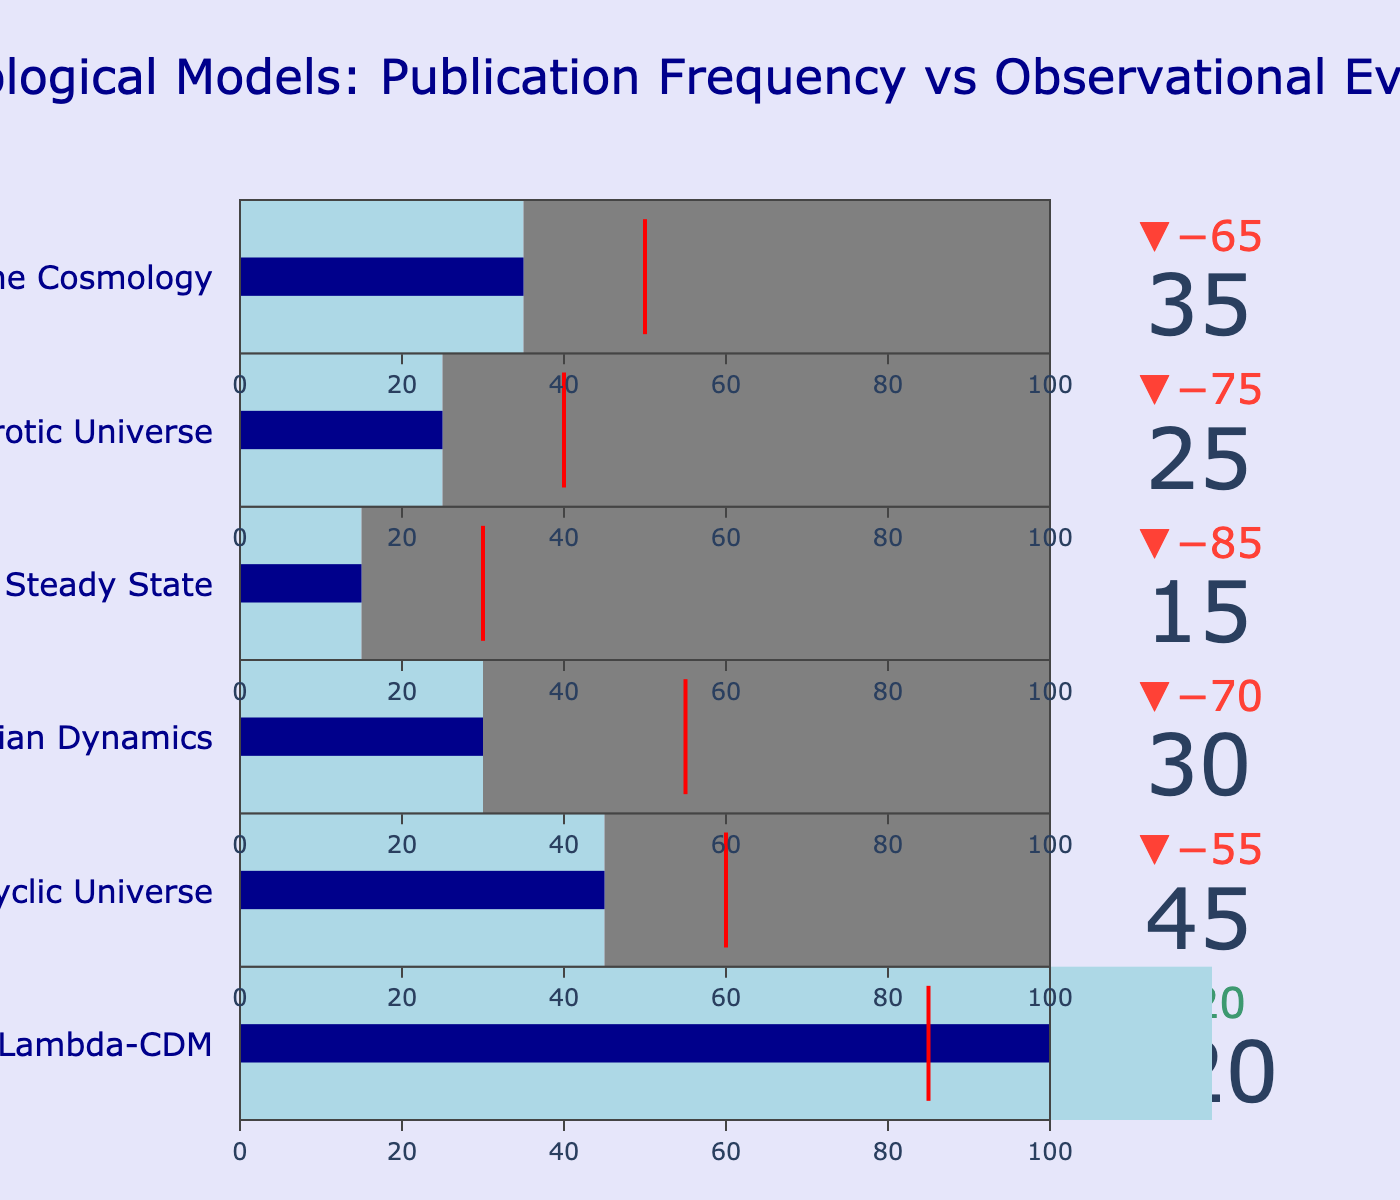What is the title of the figure? The title of the figure is displayed at the top and reads, "Cosmological Models: Publication Frequency vs Observational Evidence."
Answer: "Cosmological Models: Publication Frequency vs Observational Evidence" How many cosmological models are compared in the figure? By counting the number of bullet charts, we can see that there are six cosmological models being compared.
Answer: Six Which cosmological model has the highest number of papers published? Observing the values of "Papers Published" in each bullet chart, "Lambda-CDM" has the highest value at 120.
Answer: Lambda-CDM How much greater is the publication frequency of the Lambda-CDM model compared to the Steady State model? Subtract the "Papers Published" value of the Steady State model (15) from the Lambda-CDM model (120): 120 - 15 = 105.
Answer: 105 What is the observational evidence score for the Ekpyrotic Universe model? The observational evidence score for each model is indicated by a red threshold line in each bullet chart. For the Ekpyrotic Universe model, the score is 40.
Answer: 40 Which model has the lowest observational evidence score? Observing the red threshold lines on each bullet chart, the Steady State model has the lowest score at 30.
Answer: Steady State Compare the publication frequency against the observational evidence score for Modified Newtonian Dynamics. Is the publication frequency higher or lower? The "Papers Published" value for Modified Newtonian Dynamics is 30, whereas the observational evidence score is 55, indicating the publication frequency is lower.
Answer: Lower What percentage of the total benchmark value does the publication frequency of Brane Cosmology represent? The benchmark value is 100 for all models. The publication frequency for Brane Cosmology is 35. Calculating the percentage: (35 / 100) * 100 = 35%.
Answer: 35% Which models have a publication frequency that is less than their observational evidence score? Comparing "Papers Published" with the "Observational Evidence Score" for each model: Cyclic Universe (45 < 60), Modified Newtonian Dynamics (30 < 55), and Steady State (15 < 30) meet the criteria.
Answer: Cyclic Universe, Modified Newtonian Dynamics, Steady State For the Lambda-CDM model, what is the difference between the observational evidence score and the publication frequency? Subtract the "Papers Published" value (120) from the "Observational Evidence Score" (85): 85 - 120 = -35 (indicating the observational evidence score is 35 less than publication frequency).
Answer: -35 